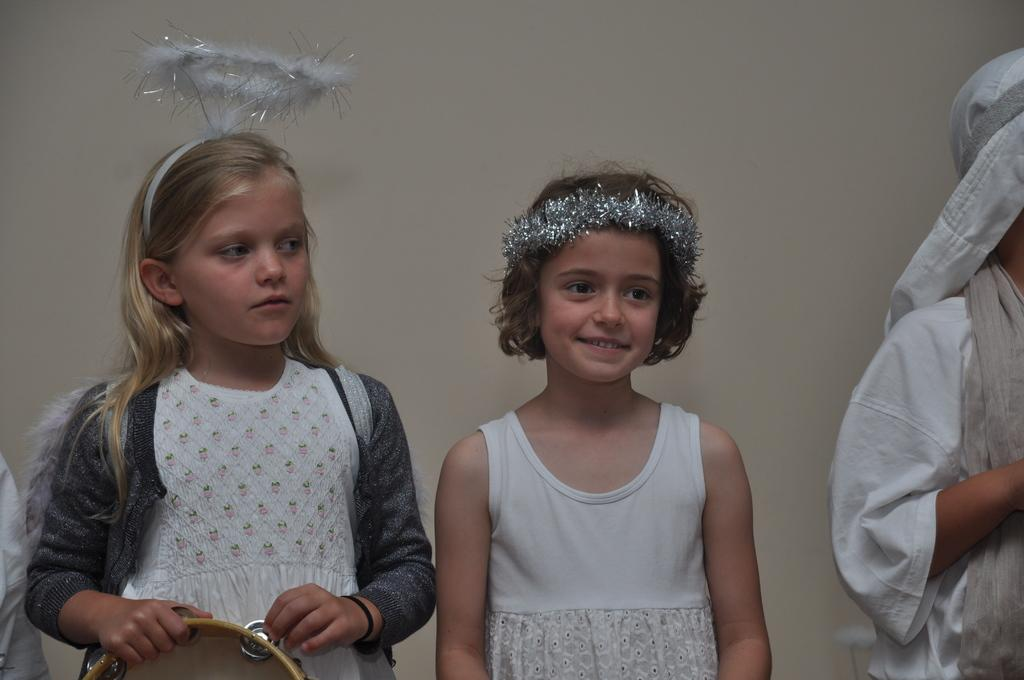How many girls are in the image? There are two girls in the image. What are the girls wearing? Both girls are wearing white dresses. Are there any other people in the image besides the girls? Yes, there is another person in the image. What type of accessory are the girls wearing in their hair? The two girls are wearing hair bands. How much sugar is in the hair bands the girls are wearing? There is no sugar present in the hair bands the girls are wearing; they are simply hair accessories. 